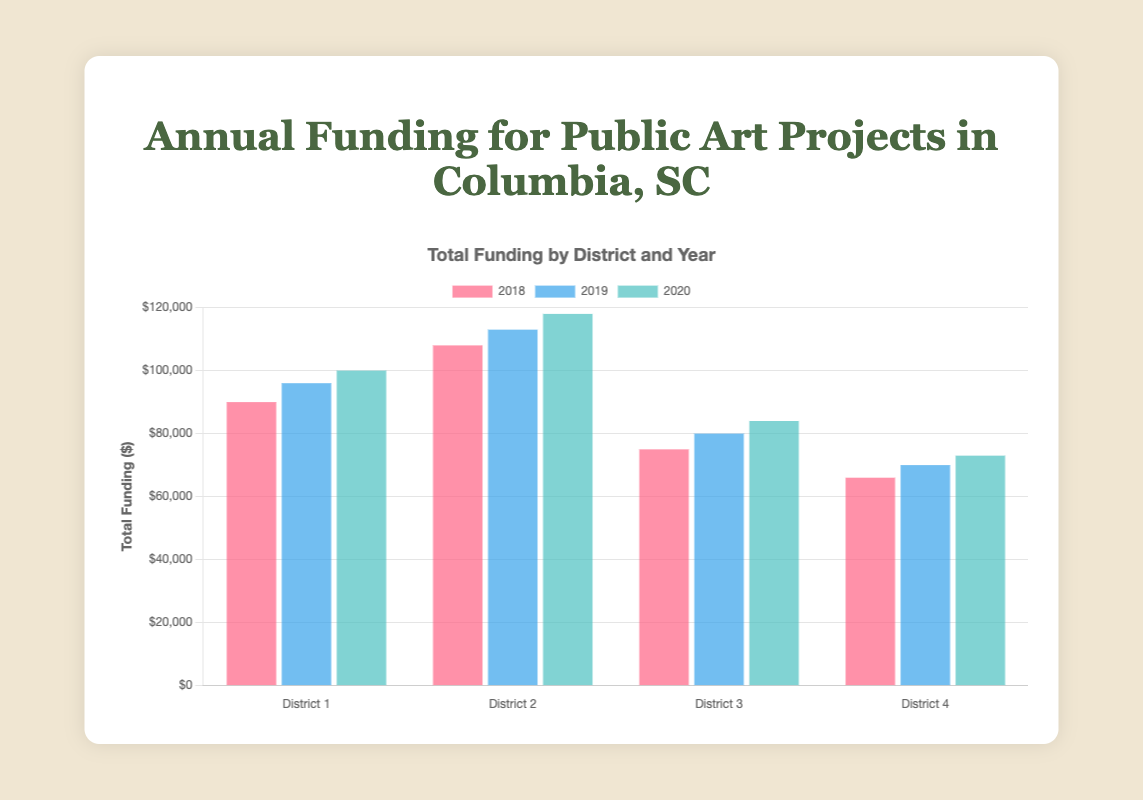Which district received the most total funding in 2020? Look at the bars labeled 2020 for each district. The one with the highest bar represents the district with the most funding.
Answer: District 2 Which year saw the greatest increase in total funding for District 1? Compare the bars for District 1 across the years. The difference from 2018 to 2019 is $96,000 - $90,000 = $6,000, and from 2019 to 2020 is $100,000 - $96,000 = $4,000.
Answer: 2019 How much more funding did District 2 receive in 2019 compared to District 4 in 2019? Look at the bars for 2019 for District 2 and District 4. Subtract the total funding for District 4 ($70,000) from District 2 ($113,000).
Answer: $43,000 What is the average total funding received by all districts in 2018? Sum the total funding for all districts in 2018 and divide by the number of districts: ($90,000 + $108,000 + $75,000 + $66,000) / 4.
Answer: $84,750 Which year had the smallest difference in total funding between District 3 and District 4? Calculate the difference in total funding for each year:
2018: $75,000 - $66,000 = $9,000,
2019: $80,000 - $70,000 = $10,000,
2020: $84,000 - $73,000 = $11,000. The smallest difference is from 2018.
Answer: 2018 From 2018 to 2020, which district showed the most consistent increase in total funding? Compare the height of the bars for each year across all districts to see which shows a regular, steady increase.
Answer: District 2 Which district received the least amount of Arts Council funding in 2020? Look at the portion of the bar representing Arts Council funding in each district for 2020 and identify the smallest one.
Answer: District 3 By how much did total funding increase for District 4 from 2018 to 2020? Subtract the total funding for District 4 in 2018 from that in 2020: $73,000 - $66,000.
Answer: $7,000 In 2019, which two districts had the closest total funding amounts? Compare the heights of the bars for 2019 across all districts to see which two are closest. District 3 and District 4 are closest with $80,000 and $70,000.
Answer: District 3 and District 4 